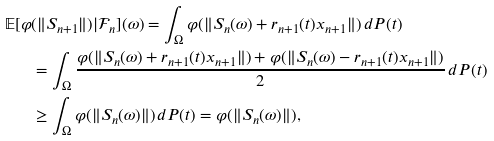<formula> <loc_0><loc_0><loc_500><loc_500>\mathbb { E } [ \varphi & ( \| S _ { n + 1 } \| ) | \mathcal { F } _ { n } ] ( \omega ) = \int _ { \Omega } \varphi ( \| S _ { n } ( \omega ) + r _ { n + 1 } ( t ) x _ { n + 1 } \| ) \, d P ( t ) \\ & = \int _ { \Omega } \frac { \varphi ( \| S _ { n } ( \omega ) + r _ { n + 1 } ( t ) x _ { n + 1 } \| ) + \varphi ( \| S _ { n } ( \omega ) - r _ { n + 1 } ( t ) x _ { n + 1 } \| ) } 2 \, d P ( t ) \\ & \geq \int _ { \Omega } \varphi ( \| S _ { n } ( \omega ) \| ) \, d P ( t ) = \varphi ( \| S _ { n } ( \omega ) \| ) ,</formula> 